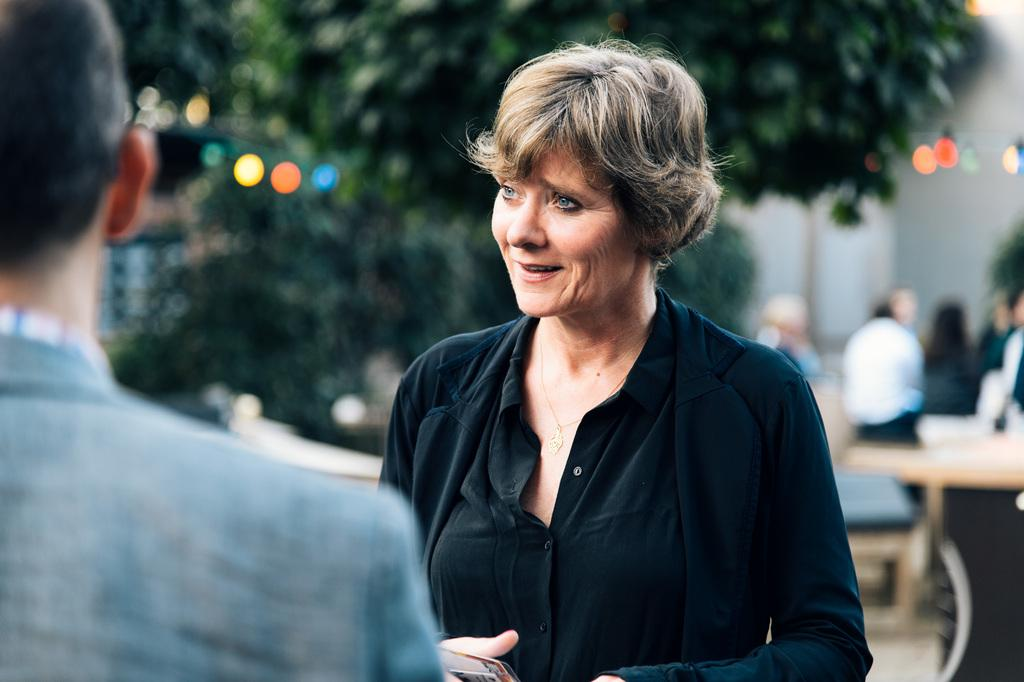What is happening on the road in the image? There is a group of people on the road in the image. What objects are present in the image besides the people? There are tables and lights visible in the image. What type of natural elements can be seen in the image? There are trees in the image. Can you determine the time of day the image was taken? The image was likely taken during the day, as there is no indication of darkness or artificial lighting. Where is the ship located in the image? There is no ship present in the image. How many sheep are visible in the image? There are no sheep present in the image. 